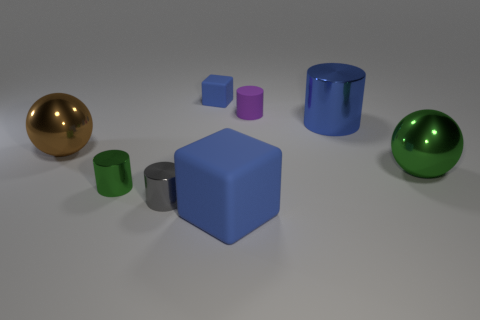What is the color of the cube that is the same size as the gray metal cylinder?
Your answer should be compact. Blue. Are any big brown metallic objects visible?
Keep it short and to the point. Yes. There is a green thing on the right side of the small gray object; what is its shape?
Give a very brief answer. Sphere. What number of objects are on the left side of the green shiny ball and behind the gray shiny cylinder?
Provide a short and direct response. 5. Is there a tiny cyan sphere made of the same material as the large block?
Offer a terse response. No. What is the size of the other rubber cube that is the same color as the tiny block?
Offer a terse response. Large. How many cubes are tiny purple rubber objects or green metal objects?
Make the answer very short. 0. How big is the brown sphere?
Offer a terse response. Large. There is a tiny purple matte cylinder; what number of small blue blocks are on the right side of it?
Offer a terse response. 0. What is the size of the metal thing in front of the small metal object left of the tiny gray shiny cylinder?
Offer a very short reply. Small. 